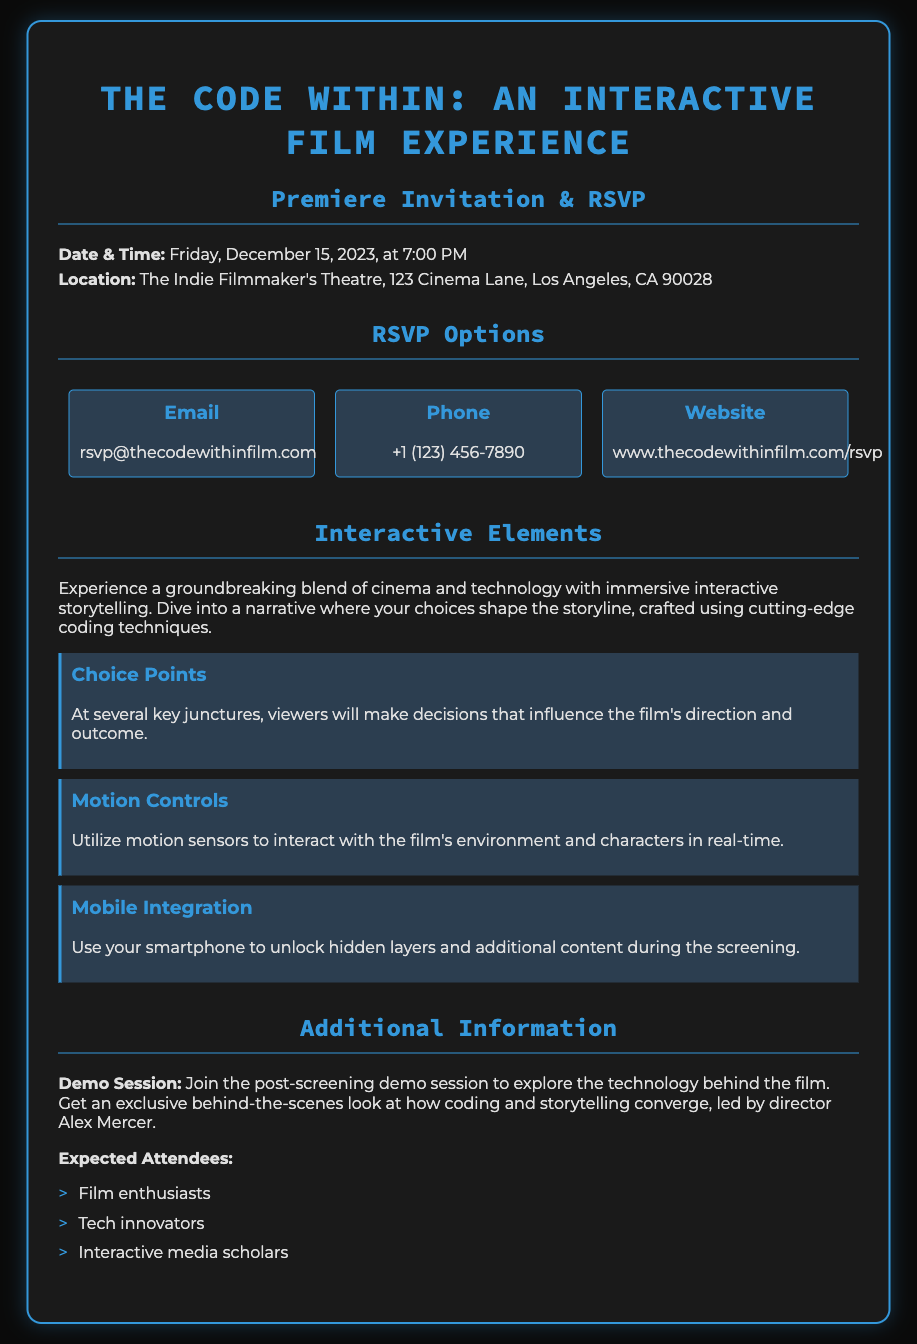What is the premiere date? The premiere date is explicitly stated in the document as Friday, December 15, 2023.
Answer: December 15, 2023 Where is the screening location? The document provides the full address for the screening location, which is The Indie Filmmaker's Theatre, 123 Cinema Lane, Los Angeles, CA 90028.
Answer: The Indie Filmmaker's Theatre, 123 Cinema Lane, Los Angeles, CA 90028 What email address should be used for RSVP? The RSVP section includes an email address for confirmation, which is rsvp@thecodewithinfilm.com.
Answer: rsvp@thecodewithinfilm.com What type of interactive element involves motion sensors? The document lists different interactive elements, one of which is explicitly identified as Motion Controls.
Answer: Motion Controls Who will lead the demo session? The additional information section mentions that the demo session will be led by the director, Alex Mercer.
Answer: Alex Mercer What is the main theme of the interactive elements? The interactive elements are designed around immersive storytelling where choices influence the narrative, which reflects the overall theme of the film.
Answer: Immersive storytelling How can attendees unlock additional content during the screening? The document details that attendees can use their smartphones to interact with the film, mentioning mobile integration as the method to unlock hidden layers.
Answer: Use your smartphone What types of attendees are expected? The additional information section lists expected attendees as film enthusiasts, tech innovators, and interactive media scholars.
Answer: Film enthusiasts, tech innovators, interactive media scholars 